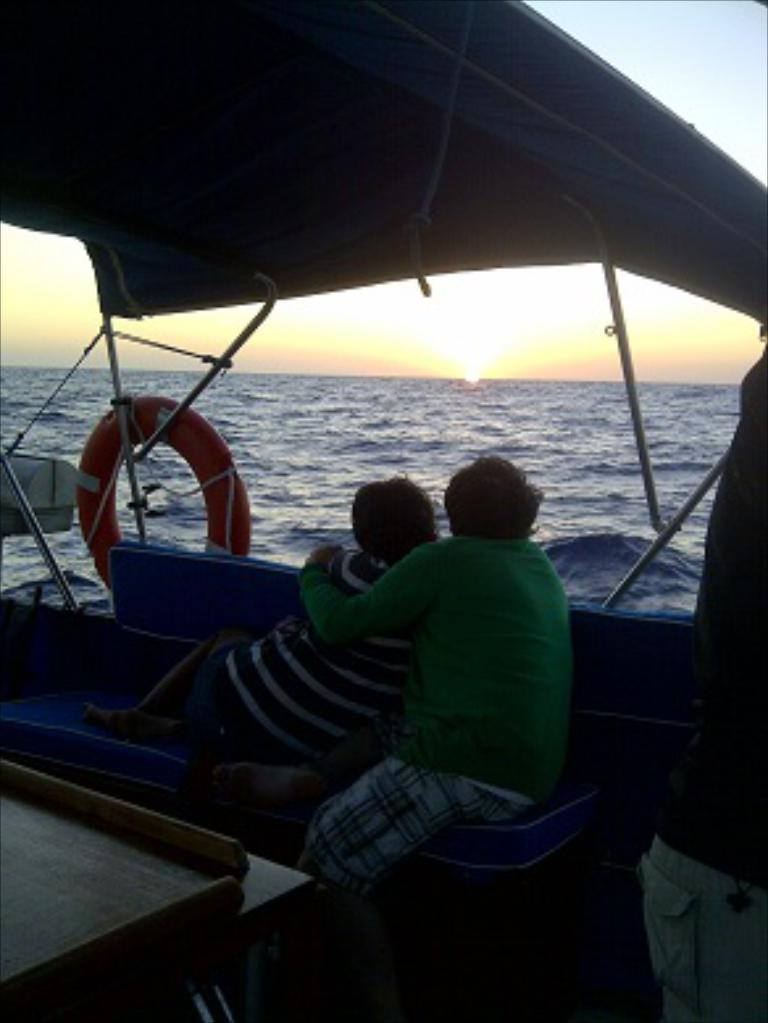What are the people in the image doing? The persons in the image are sitting on a boat. Where is the boat located? The boat is in the ocean. What can be seen in the sky in the background of the image? The sun is setting down in the sky in the background of the image. What type of wool is being used to make the boat in the image? There is no wool present in the image, and the boat is not being made in the image. 